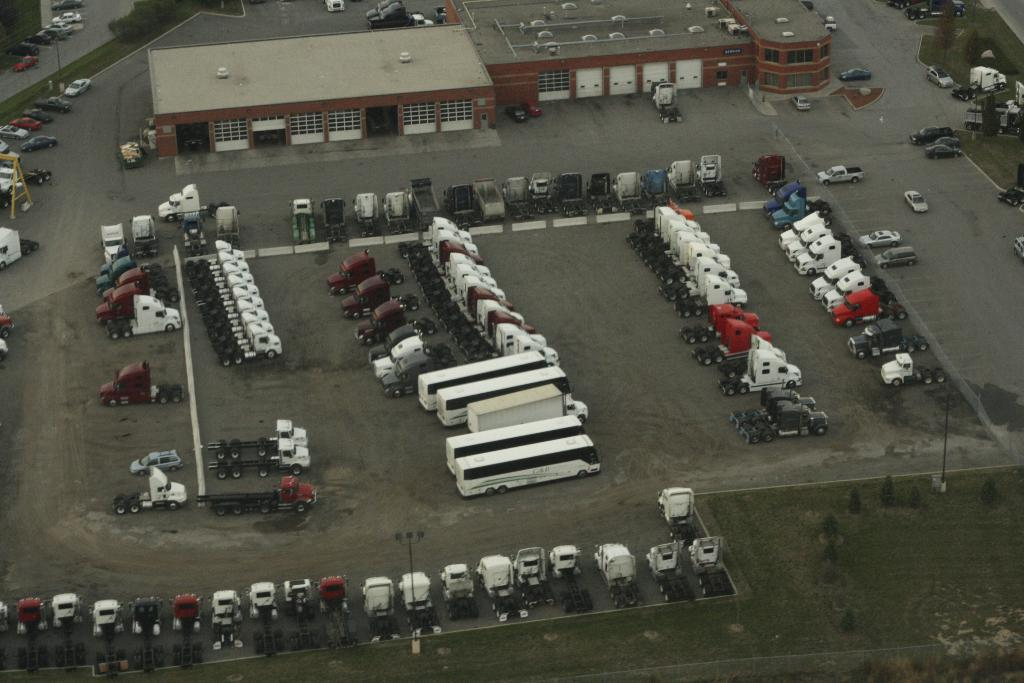What types of objects are present on the ground in the image? There are vehicles and electric poles on the ground in the image. What can be found near the vehicles and electric poles? The vehicles and electric poles are on the ground, so they are likely near sheds visible in the background of the image. What is the taste of the parcel in the image? There is no parcel present in the image, so it is not possible to determine its taste. 